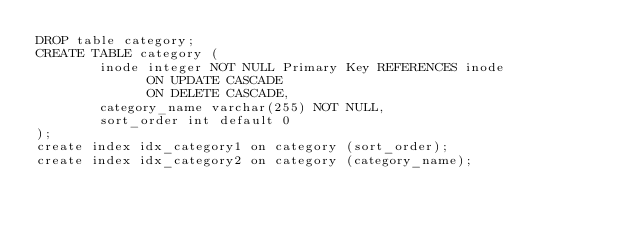Convert code to text. <code><loc_0><loc_0><loc_500><loc_500><_SQL_>DROP table category;
CREATE TABLE category (
        inode integer NOT NULL Primary Key REFERENCES inode 
              ON UPDATE CASCADE  
              ON DELETE CASCADE, 
        category_name varchar(255) NOT NULL,
      	sort_order int default 0
);
create index idx_category1 on category (sort_order);
create index idx_category2 on category (category_name);


</code> 